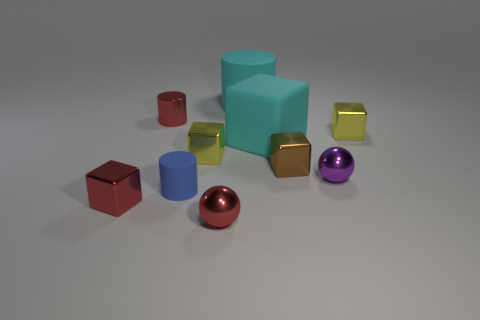Subtract 1 cubes. How many cubes are left? 4 Subtract all cyan blocks. How many blocks are left? 4 Subtract all large cyan matte cubes. How many cubes are left? 4 Subtract all green cubes. Subtract all cyan cylinders. How many cubes are left? 5 Subtract all balls. How many objects are left? 8 Add 7 big cyan cylinders. How many big cyan cylinders exist? 8 Subtract 1 cyan cylinders. How many objects are left? 9 Subtract all big yellow cubes. Subtract all small spheres. How many objects are left? 8 Add 4 red things. How many red things are left? 7 